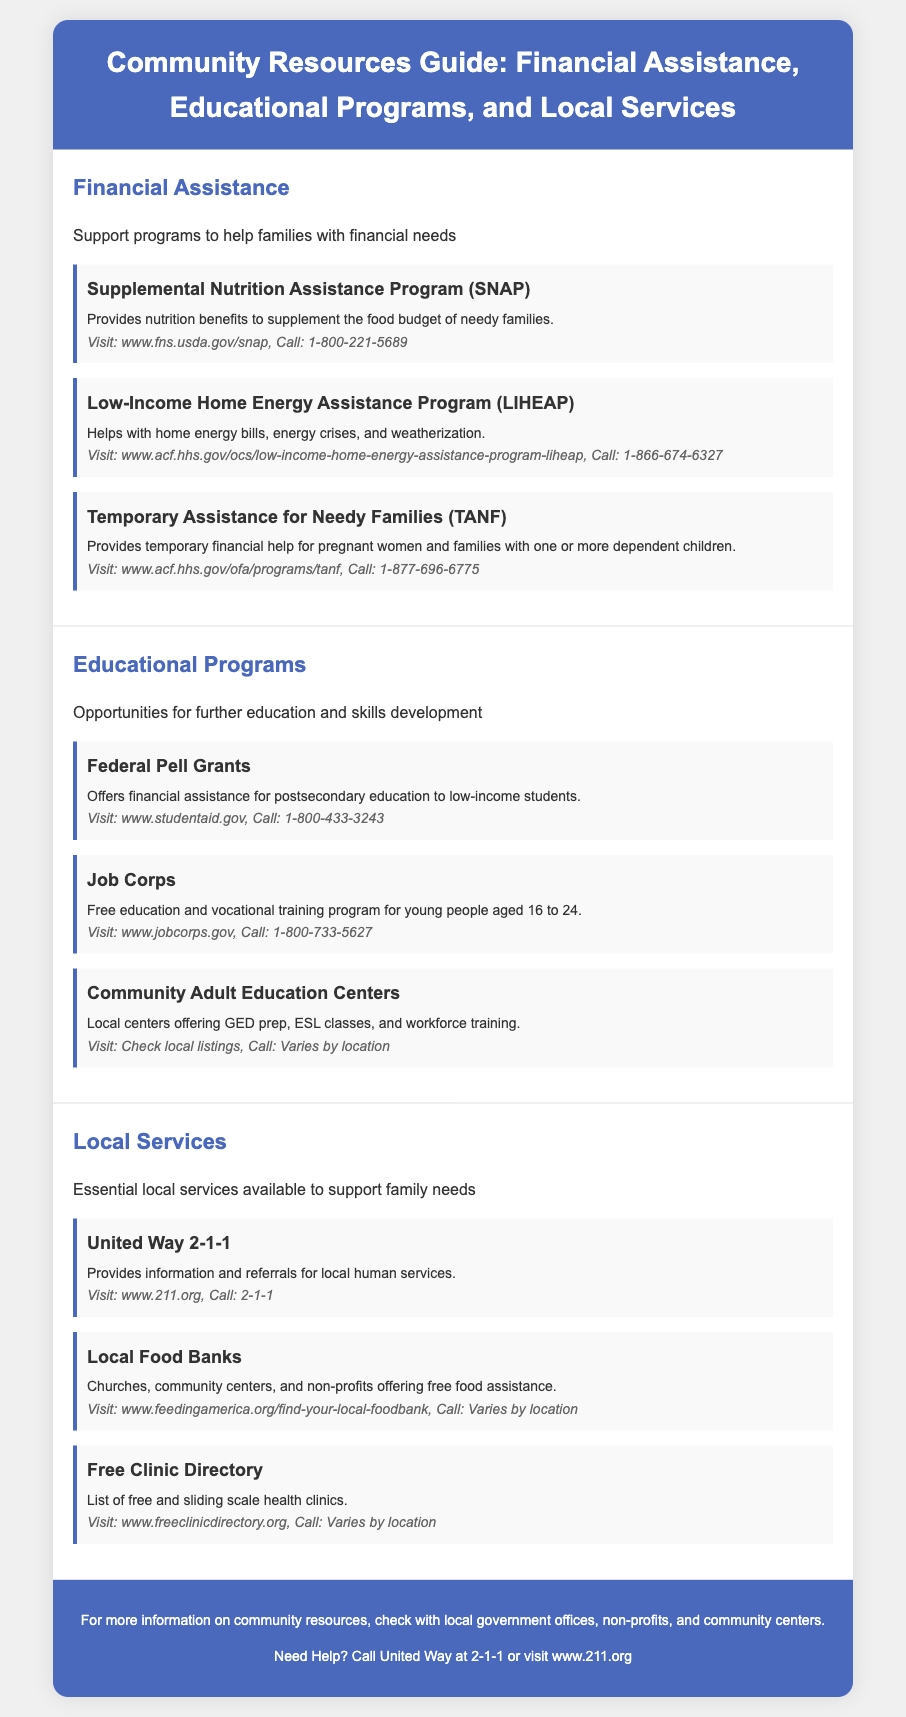What program provides nutrition benefits? The program that provides nutrition benefits is SNAP.
Answer: SNAP How can I contact the Low-Income Home Energy Assistance Program? The contact information for LIHEAP is available; call 1-866-674-6327.
Answer: 1-866-674-6327 What age group does Job Corps serve? Job Corps serves young people aged 16 to 24.
Answer: 16 to 24 What type of assistance do local food banks offer? Local food banks offer free food assistance.
Answer: Free food assistance How many financial assistance programs are listed in the document? There are three financial assistance programs listed in the section.
Answer: Three What is the website for the United Way 2-1-1? The website for United Way 2-1-1 is www.211.org.
Answer: www.211.org What do Community Adult Education Centers offer? Community Adult Education Centers offer GED prep, ESL classes, and workforce training.
Answer: GED prep, ESL classes, workforce training Which federal program offers grants for low-income students? The federal program that offers grants is Federal Pell Grants.
Answer: Federal Pell Grants What type of services does the Free Clinic Directory provide? The Free Clinic Directory provides a list of free and sliding scale health clinics.
Answer: Free and sliding scale health clinics 